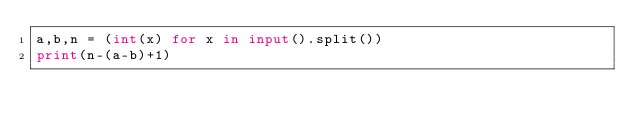Convert code to text. <code><loc_0><loc_0><loc_500><loc_500><_Python_>a,b,n = (int(x) for x in input().split())
print(n-(a-b)+1)</code> 